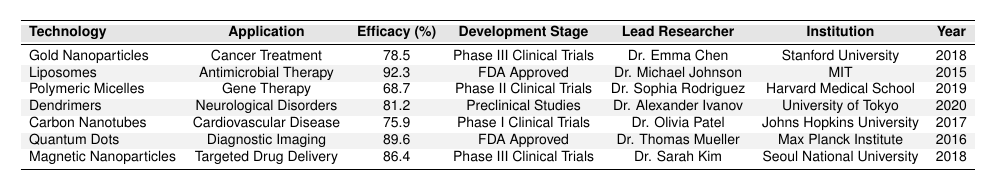What is the highest efficacy rate among the technologies listed? The efficacy rates for the technologies are as follows: Gold Nanoparticles (78.5%), Liposomes (92.3%), Polymeric Micelles (68.7%), Dendrimers (81.2%), Carbon Nanotubes (75.9%), Quantum Dots (89.6%), and Magnetic Nanoparticles (86.4%). The highest efficacy rate is 92.3%.
Answer: 92.3% Who is the lead researcher for the research involving Dendrimers? Referring to the table, Dendrimers are associated with Dr. Alexander Ivanov as the lead researcher.
Answer: Dr. Alexander Ivanov How many technologies are in Phase III Clinical Trials? The technologies in Phase III Clinical Trials are Gold Nanoparticles and Magnetic Nanoparticles, making a total of 2 technologies in this stage.
Answer: 2 Which technology has the lowest efficacy rate and what is that rate? The efficacy rates listed show that Polymeric Micelles have the lowest efficacy rate at 68.7%.
Answer: 68.7% Is there a technology that is FDA Approved and has an efficacy rate greater than 90%? The table shows that Liposomes and Quantum Dots are both FDA Approved, and that Liposomes have an efficacy rate of 92.3%, which is greater than 90%.
Answer: Yes What is the difference in efficacy rate between the most effective and the least effective technology? The most effective technology is Liposomes with 92.3% and the least effective is Polymeric Micelles with 68.7%. Their difference is calculated as 92.3% - 68.7% = 23.6%.
Answer: 23.6% Which institution is associated with the research on Magnetic Nanoparticles? According to the table, the research on Magnetic Nanoparticles is associated with Seoul National University.
Answer: Seoul National University What percentage of the technologies listed are still in the experimental development stages (not FDA Approved)? The technologies not FDA Approved are Gold Nanoparticles, Polymeric Micelles, Dendrimers, and Carbon Nanotubes (4 out of 7 technologies). To find the percentage, (4/7) * 100 ≈ 57.14%.
Answer: Approximately 57.14% Which technology has a patent status that is "Patent Pending"? The table states that Polymeric Micelles and Magnetic Nanoparticles have a patent status of "Patent Pending".
Answer: Polymeric Micelles and Magnetic Nanoparticles What is the development stage of the technology with the highest efficacy rate? The technology Liposomes, which has the highest efficacy rate of 92.3%, is in the FDA Approved stage.
Answer: FDA Approved How many researchers are affiliated with institutions located in the United States? Researchers from Stanford University (Dr. Emma Chen), MIT (Dr. Michael Johnson), Harvard Medical School (Dr. Sophia Rodriguez), and Johns Hopkins University (Dr. Olivia Patel) are affiliated with U.S. institutions, totaling 4 researchers.
Answer: 4 